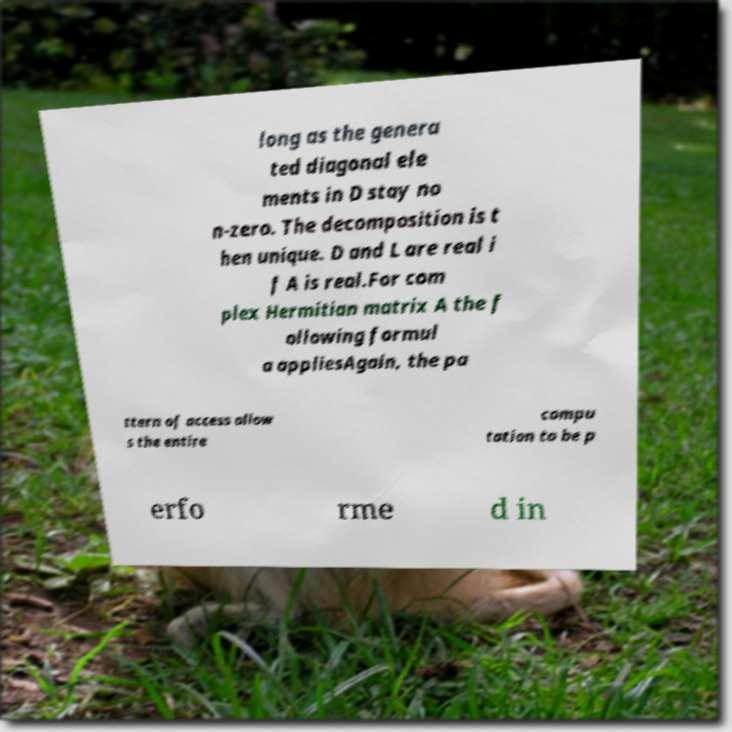What messages or text are displayed in this image? I need them in a readable, typed format. long as the genera ted diagonal ele ments in D stay no n-zero. The decomposition is t hen unique. D and L are real i f A is real.For com plex Hermitian matrix A the f ollowing formul a appliesAgain, the pa ttern of access allow s the entire compu tation to be p erfo rme d in 